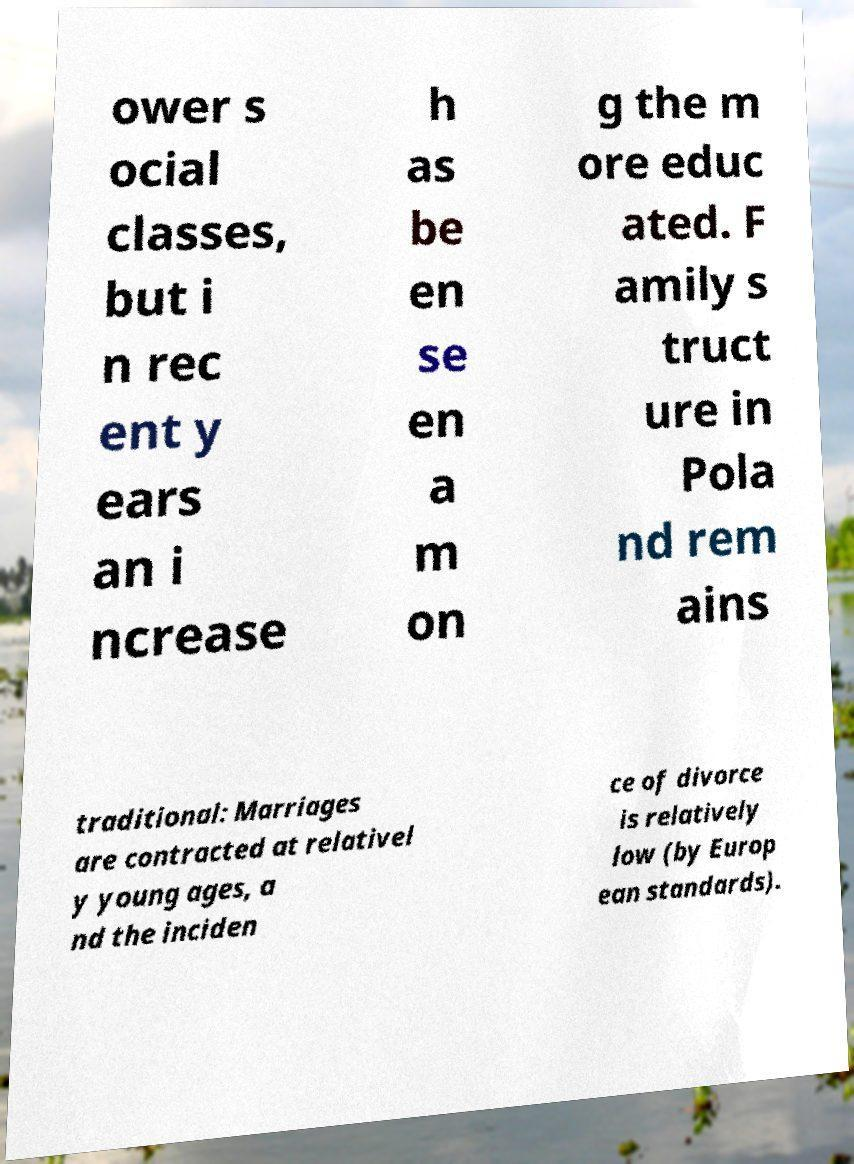There's text embedded in this image that I need extracted. Can you transcribe it verbatim? ower s ocial classes, but i n rec ent y ears an i ncrease h as be en se en a m on g the m ore educ ated. F amily s truct ure in Pola nd rem ains traditional: Marriages are contracted at relativel y young ages, a nd the inciden ce of divorce is relatively low (by Europ ean standards). 